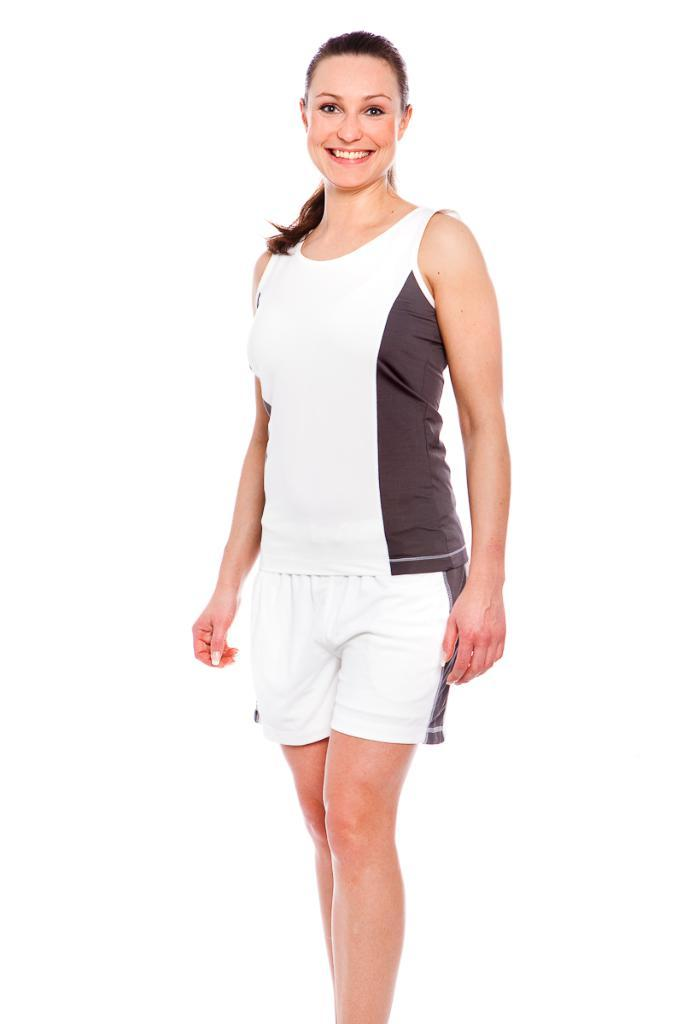Who is the main subject in the image? There is a lady in the image. What is the lady wearing? The lady is wearing white shorts. What caption is written on the lady's shirt in the image? There is no caption visible on the lady's shirt in the image. What type of noise can be heard coming from the lady in the image? There is no noise coming from the lady in the image, as it is a still image. 